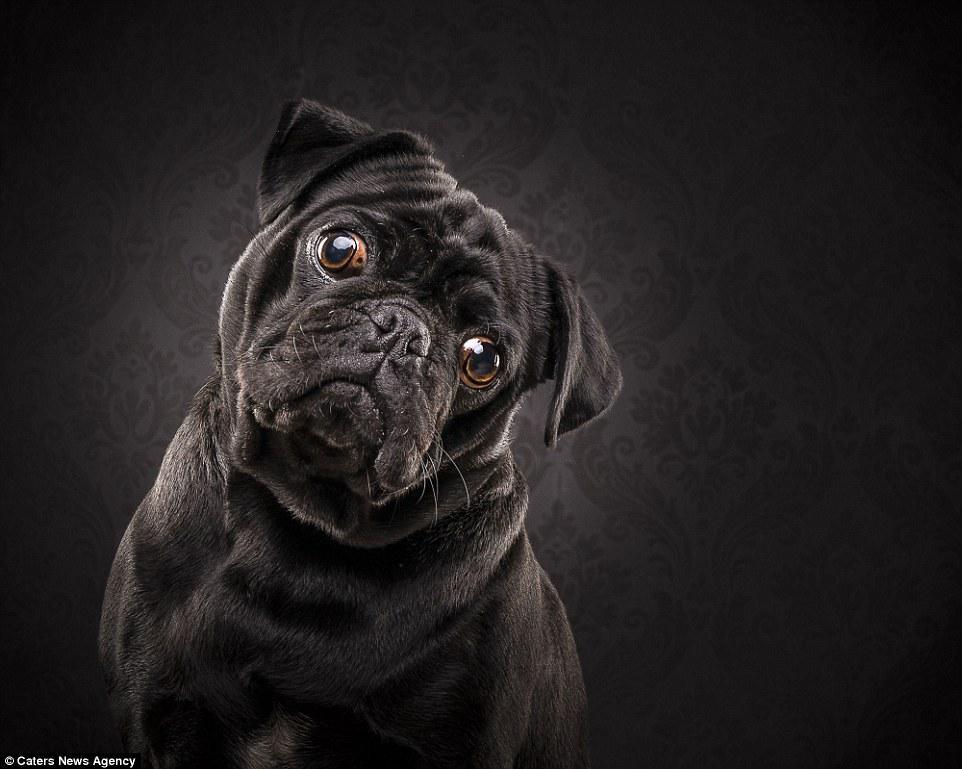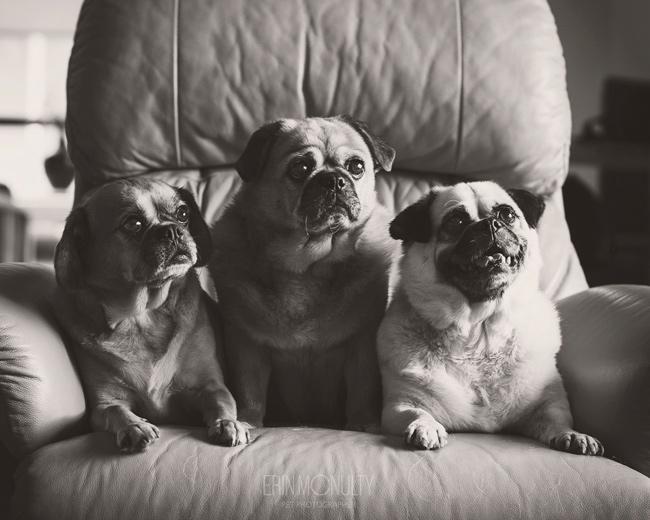The first image is the image on the left, the second image is the image on the right. Analyze the images presented: Is the assertion "There is one pug dog facing front, and at least one pug dog with its head turned slightly to the right." valid? Answer yes or no. Yes. The first image is the image on the left, the second image is the image on the right. For the images shown, is this caption "At least one pug is laying down." true? Answer yes or no. Yes. 